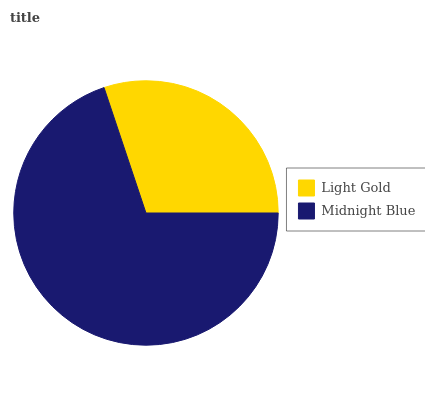Is Light Gold the minimum?
Answer yes or no. Yes. Is Midnight Blue the maximum?
Answer yes or no. Yes. Is Midnight Blue the minimum?
Answer yes or no. No. Is Midnight Blue greater than Light Gold?
Answer yes or no. Yes. Is Light Gold less than Midnight Blue?
Answer yes or no. Yes. Is Light Gold greater than Midnight Blue?
Answer yes or no. No. Is Midnight Blue less than Light Gold?
Answer yes or no. No. Is Midnight Blue the high median?
Answer yes or no. Yes. Is Light Gold the low median?
Answer yes or no. Yes. Is Light Gold the high median?
Answer yes or no. No. Is Midnight Blue the low median?
Answer yes or no. No. 